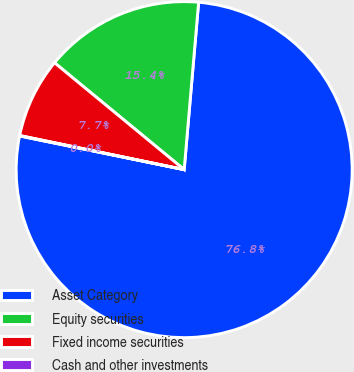Convert chart to OTSL. <chart><loc_0><loc_0><loc_500><loc_500><pie_chart><fcel>Asset Category<fcel>Equity securities<fcel>Fixed income securities<fcel>Cash and other investments<nl><fcel>76.84%<fcel>15.4%<fcel>7.72%<fcel>0.04%<nl></chart> 